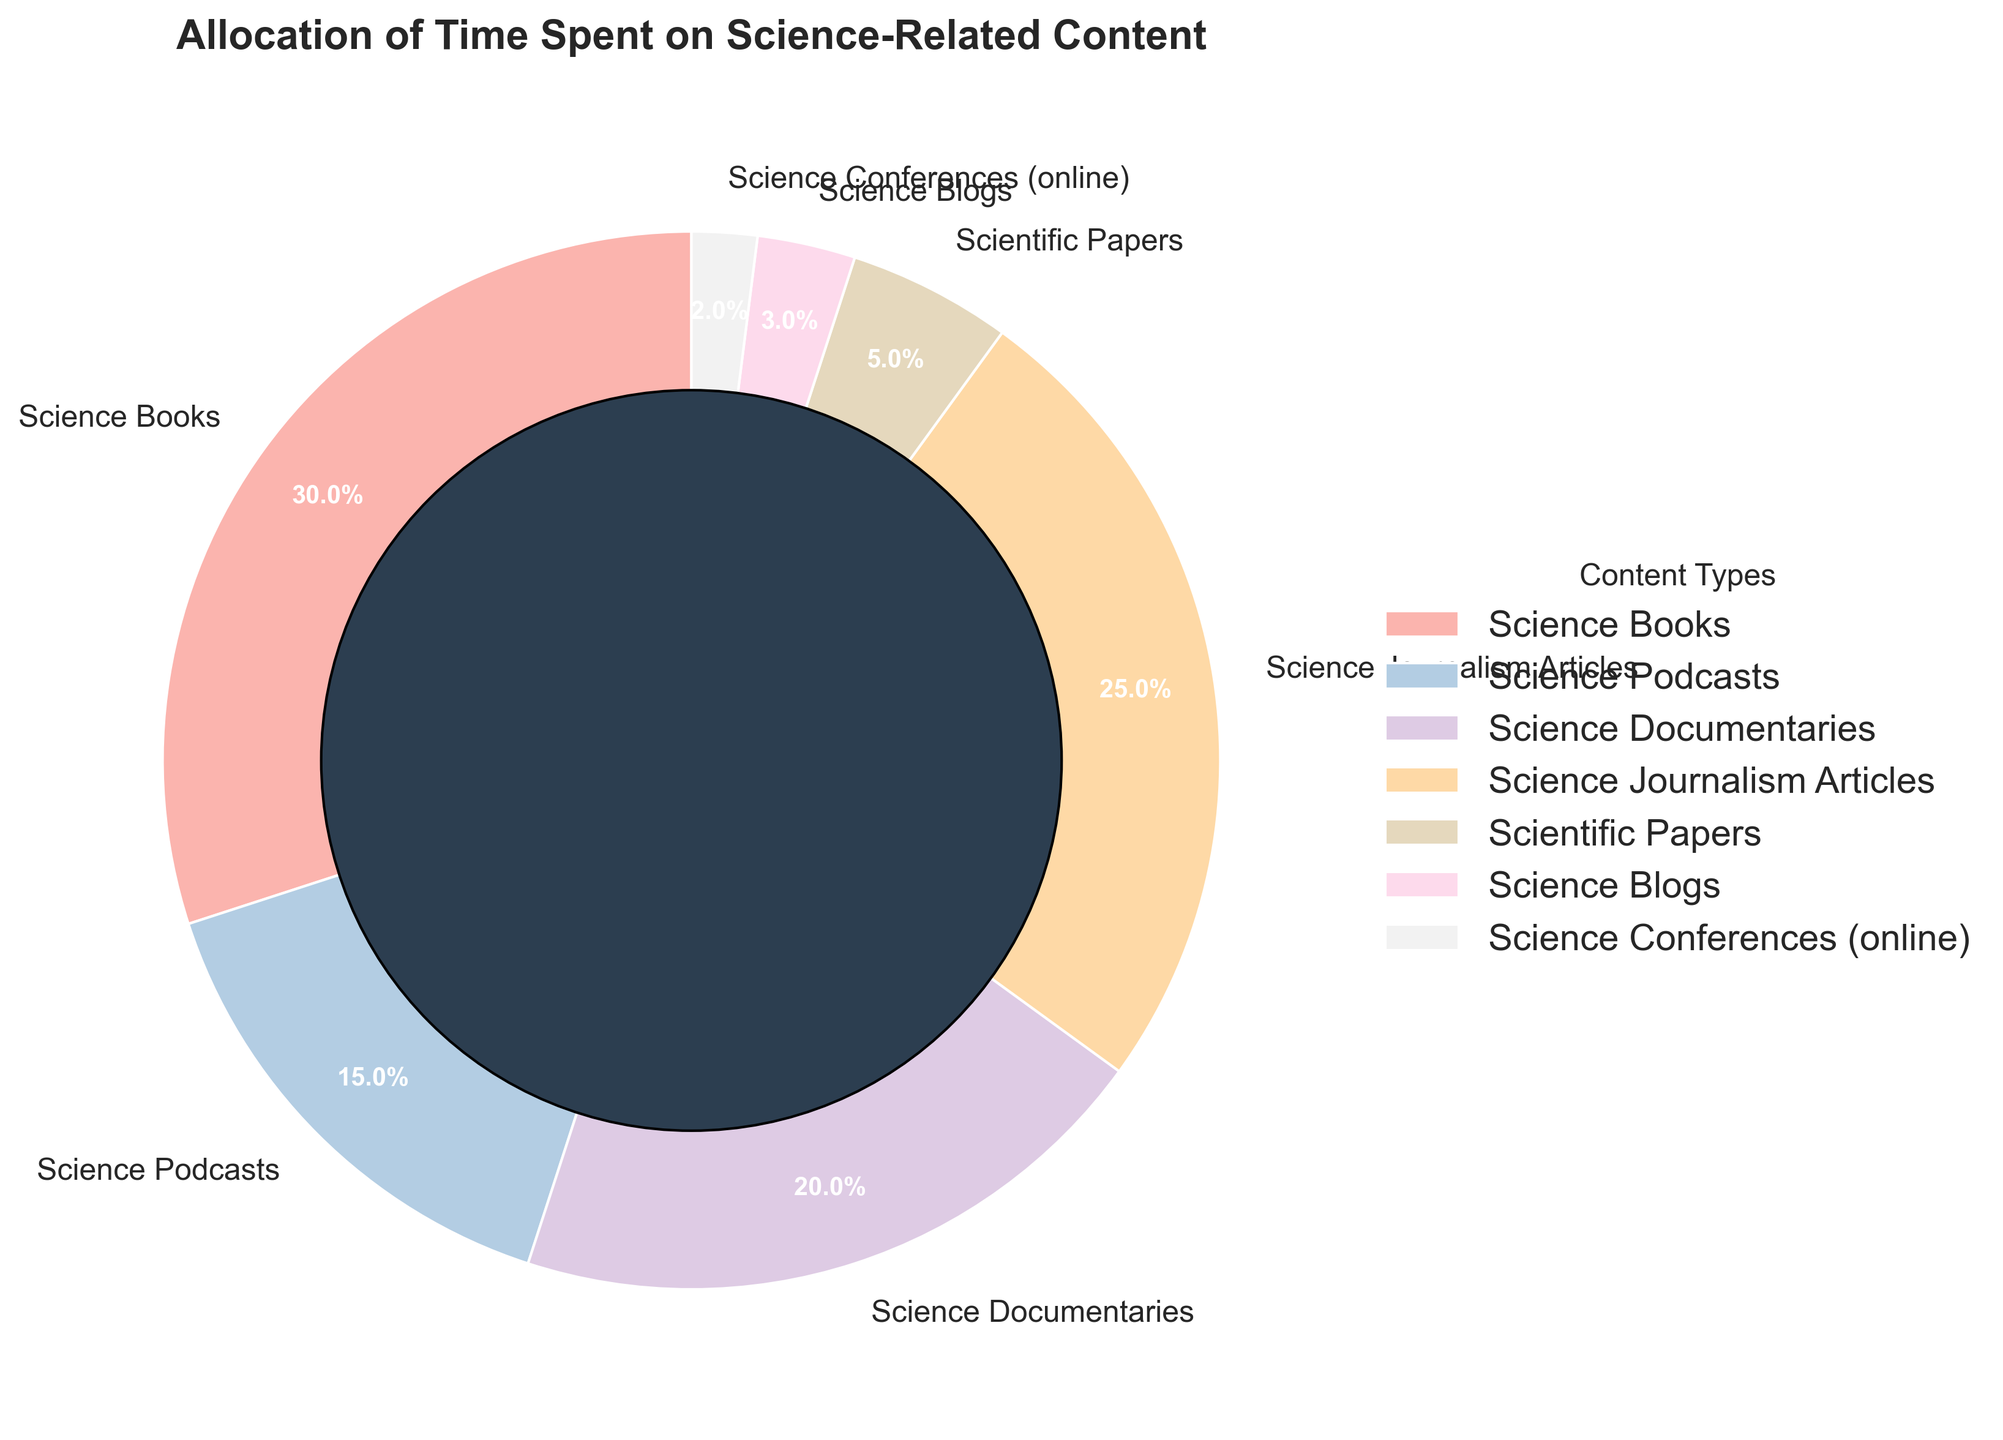Which content type receives the highest percentage of time allocation? The pie chart shows that "Science Books" have the largest segment, labeled as 30%.
Answer: Science Books What is the combined percentage of time spent on Science Blogs and Science Conferences? Locate the segments for Science Blogs (3%) and Science Conferences (2%) in the pie chart. Add 3% + 2% to get the total.
Answer: 5% Is more time spent on Science Documentaries or Science Podcasts? Compare the slices labeled as "Science Documentaries" (20%) and "Science Podcasts" (15%). The slice for Science Documentaries is larger.
Answer: Science Documentaries What is the percentage difference between time spent on Science Journalism Articles and Science Books? Find the labels for Science Journalism Articles (25%) and Science Books (30%). Subtract the smaller percentage from the larger one: 30% - 25% = 5%.
Answer: 5% What fraction of the total time is allocated to Scientific Papers? Locate the slice for Scientific Papers, labeled 5%. Since the total percentage is 100%, 5% is equivalent to 5/100 or 1/20.
Answer: 1/20 Among Science Podcasts, Science Documentaries, and Science Journalism Articles, which receives the least amount of time? Look at the segments for Science Podcasts (15%), Science Documentaries (20%), and Science Journalism Articles (25%). The smallest percentage is for Science Podcasts.
Answer: Science Podcasts How much more percentage is allocated to Science Journalism Articles compared to Scientific Papers? Identify the segments for Science Journalism Articles (25%) and Scientific Papers (5%). Subtract the smaller percentage from the larger one: 25% - 5% = 20%.
Answer: 20% What color is the segment for Science Blogs? Visually inspect the pie chart and identify the slice labeled "Science Blogs". Recognize the associated color, which is likely a light pastel color given the palette used.
Answer: Light pastel color 